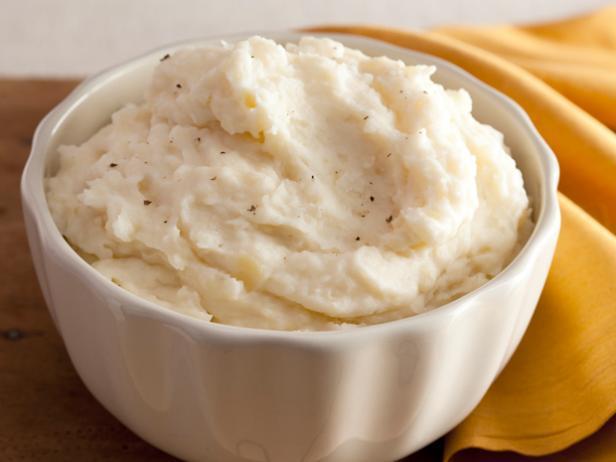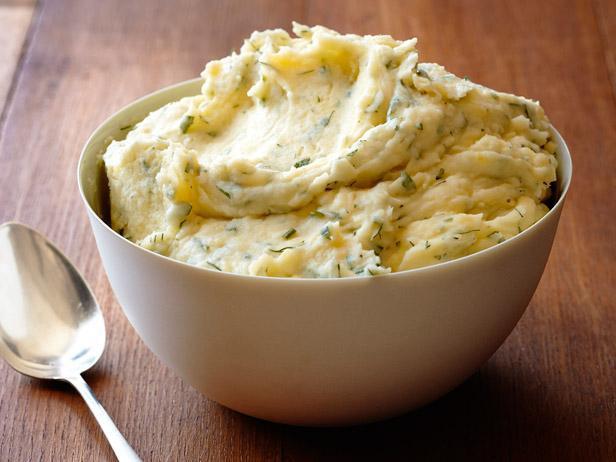The first image is the image on the left, the second image is the image on the right. Considering the images on both sides, is "Large flakes of green garnish adorn the potatoes in the image on left." valid? Answer yes or no. No. The first image is the image on the left, the second image is the image on the right. Analyze the images presented: Is the assertion "One image shows food in a white bowl, and the other does not." valid? Answer yes or no. No. 